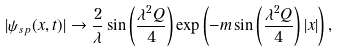<formula> <loc_0><loc_0><loc_500><loc_500>| \psi _ { s p } ( x , t ) | \rightarrow \frac { 2 } { \lambda } \sin \left ( \frac { \lambda ^ { 2 } Q } { 4 } \right ) \exp \left ( - m \sin \left ( \frac { \lambda ^ { 2 } Q } { 4 } \right ) | x | \right ) ,</formula> 